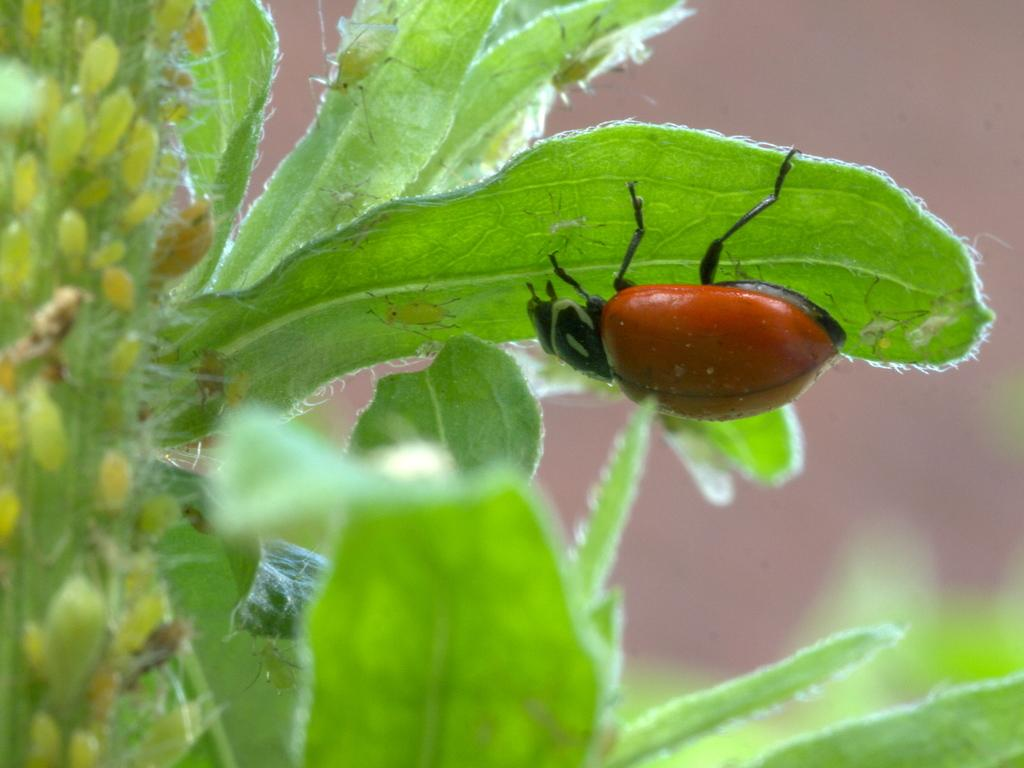What type of creatures can be seen in the image? There are insects in the image. Where are the insects located? The insects are on green leaves. What color is the background of the image? The background of the image is pink. What type of reaction can be seen in the notebook in the image? There is no notebook present in the image, so it is not possible to determine if there is any reaction. 